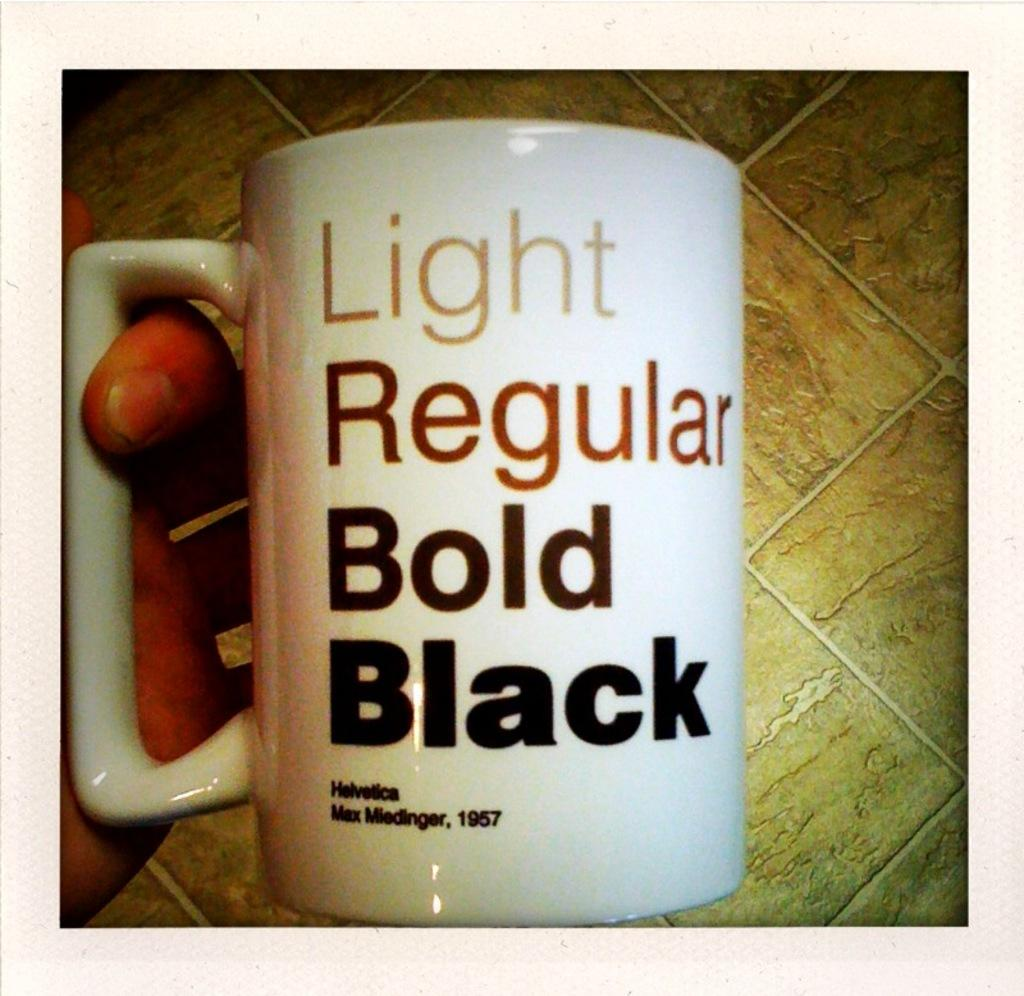<image>
Present a compact description of the photo's key features. a cup that has bold black written on it 